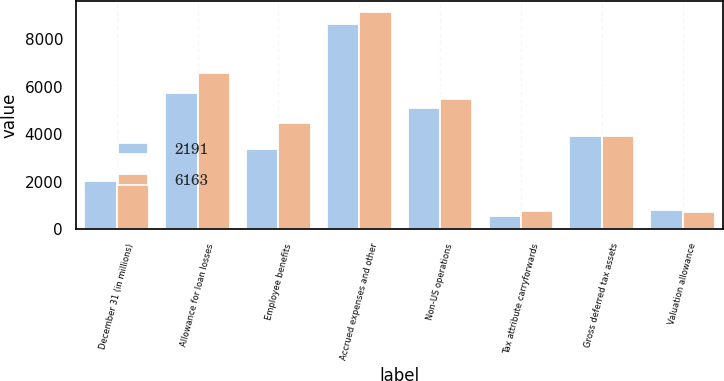Convert chart. <chart><loc_0><loc_0><loc_500><loc_500><stacked_bar_chart><ecel><fcel>December 31 (in millions)<fcel>Allowance for loan losses<fcel>Employee benefits<fcel>Accrued expenses and other<fcel>Non-US operations<fcel>Tax attribute carryforwards<fcel>Gross deferred tax assets<fcel>Valuation allowance<nl><fcel>2191<fcel>2014<fcel>5756<fcel>3378<fcel>8637<fcel>5106<fcel>570<fcel>3923<fcel>820<nl><fcel>6163<fcel>2013<fcel>6593<fcel>4468<fcel>9179<fcel>5493<fcel>748<fcel>3923<fcel>724<nl></chart> 